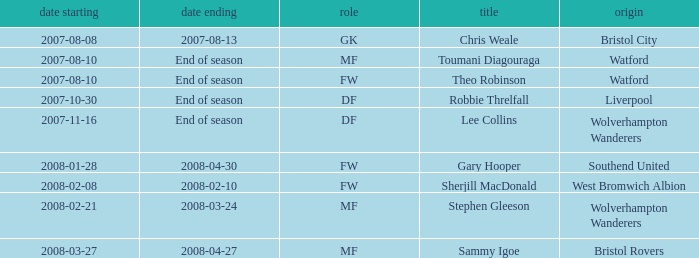What was the from for the Date From of 2007-08-08? Bristol City. 